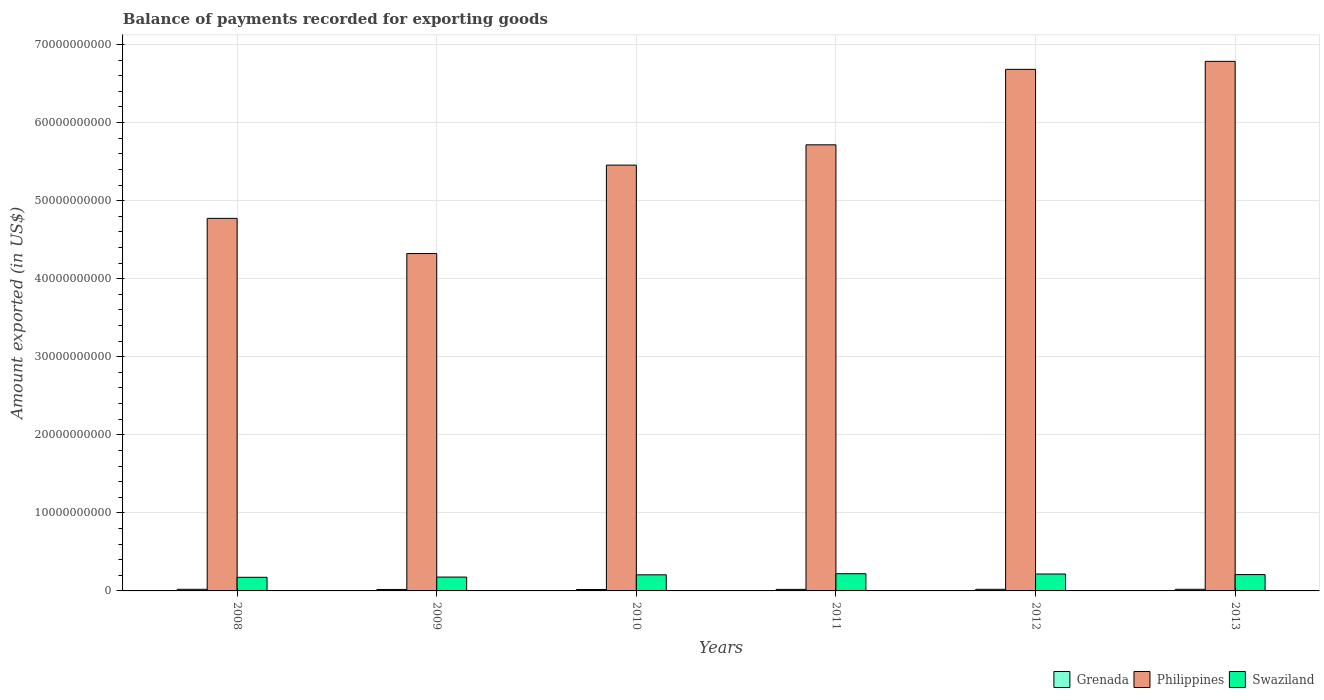How many groups of bars are there?
Provide a short and direct response. 6. Are the number of bars per tick equal to the number of legend labels?
Keep it short and to the point. Yes. Are the number of bars on each tick of the X-axis equal?
Your answer should be very brief. Yes. In how many cases, is the number of bars for a given year not equal to the number of legend labels?
Offer a very short reply. 0. What is the amount exported in Swaziland in 2013?
Provide a succinct answer. 2.09e+09. Across all years, what is the maximum amount exported in Swaziland?
Provide a succinct answer. 2.21e+09. Across all years, what is the minimum amount exported in Philippines?
Make the answer very short. 4.32e+1. In which year was the amount exported in Grenada maximum?
Your response must be concise. 2013. What is the total amount exported in Grenada in the graph?
Provide a short and direct response. 1.19e+09. What is the difference between the amount exported in Grenada in 2012 and that in 2013?
Ensure brevity in your answer.  -3.25e+06. What is the difference between the amount exported in Swaziland in 2008 and the amount exported in Grenada in 2012?
Ensure brevity in your answer.  1.54e+09. What is the average amount exported in Swaziland per year?
Your response must be concise. 2.01e+09. In the year 2008, what is the difference between the amount exported in Philippines and amount exported in Grenada?
Provide a short and direct response. 4.75e+1. In how many years, is the amount exported in Swaziland greater than 34000000000 US$?
Keep it short and to the point. 0. What is the ratio of the amount exported in Grenada in 2012 to that in 2013?
Make the answer very short. 0.98. What is the difference between the highest and the second highest amount exported in Grenada?
Make the answer very short. 1.94e+06. What is the difference between the highest and the lowest amount exported in Philippines?
Offer a terse response. 2.46e+1. What does the 3rd bar from the left in 2012 represents?
Make the answer very short. Swaziland. What does the 3rd bar from the right in 2008 represents?
Make the answer very short. Grenada. Is it the case that in every year, the sum of the amount exported in Swaziland and amount exported in Philippines is greater than the amount exported in Grenada?
Make the answer very short. Yes. What is the difference between two consecutive major ticks on the Y-axis?
Provide a short and direct response. 1.00e+1. Does the graph contain grids?
Give a very brief answer. Yes. How many legend labels are there?
Provide a short and direct response. 3. How are the legend labels stacked?
Make the answer very short. Horizontal. What is the title of the graph?
Your response must be concise. Balance of payments recorded for exporting goods. Does "Brazil" appear as one of the legend labels in the graph?
Your response must be concise. No. What is the label or title of the Y-axis?
Ensure brevity in your answer.  Amount exported (in US$). What is the Amount exported (in US$) of Grenada in 2008?
Provide a succinct answer. 2.08e+08. What is the Amount exported (in US$) in Philippines in 2008?
Give a very brief answer. 4.77e+1. What is the Amount exported (in US$) in Swaziland in 2008?
Give a very brief answer. 1.74e+09. What is the Amount exported (in US$) of Grenada in 2009?
Make the answer very short. 1.87e+08. What is the Amount exported (in US$) in Philippines in 2009?
Offer a very short reply. 4.32e+1. What is the Amount exported (in US$) of Swaziland in 2009?
Offer a terse response. 1.78e+09. What is the Amount exported (in US$) of Grenada in 2010?
Provide a short and direct response. 1.84e+08. What is the Amount exported (in US$) in Philippines in 2010?
Offer a terse response. 5.46e+1. What is the Amount exported (in US$) of Swaziland in 2010?
Your response must be concise. 2.06e+09. What is the Amount exported (in US$) in Grenada in 2011?
Give a very brief answer. 1.96e+08. What is the Amount exported (in US$) of Philippines in 2011?
Ensure brevity in your answer.  5.72e+1. What is the Amount exported (in US$) of Swaziland in 2011?
Ensure brevity in your answer.  2.21e+09. What is the Amount exported (in US$) of Grenada in 2012?
Ensure brevity in your answer.  2.06e+08. What is the Amount exported (in US$) in Philippines in 2012?
Your response must be concise. 6.68e+1. What is the Amount exported (in US$) in Swaziland in 2012?
Keep it short and to the point. 2.17e+09. What is the Amount exported (in US$) of Grenada in 2013?
Ensure brevity in your answer.  2.10e+08. What is the Amount exported (in US$) in Philippines in 2013?
Keep it short and to the point. 6.78e+1. What is the Amount exported (in US$) in Swaziland in 2013?
Provide a short and direct response. 2.09e+09. Across all years, what is the maximum Amount exported (in US$) of Grenada?
Your response must be concise. 2.10e+08. Across all years, what is the maximum Amount exported (in US$) in Philippines?
Your response must be concise. 6.78e+1. Across all years, what is the maximum Amount exported (in US$) in Swaziland?
Ensure brevity in your answer.  2.21e+09. Across all years, what is the minimum Amount exported (in US$) in Grenada?
Your answer should be very brief. 1.84e+08. Across all years, what is the minimum Amount exported (in US$) of Philippines?
Give a very brief answer. 4.32e+1. Across all years, what is the minimum Amount exported (in US$) of Swaziland?
Make the answer very short. 1.74e+09. What is the total Amount exported (in US$) of Grenada in the graph?
Give a very brief answer. 1.19e+09. What is the total Amount exported (in US$) of Philippines in the graph?
Provide a succinct answer. 3.37e+11. What is the total Amount exported (in US$) of Swaziland in the graph?
Ensure brevity in your answer.  1.20e+1. What is the difference between the Amount exported (in US$) in Grenada in 2008 and that in 2009?
Keep it short and to the point. 2.06e+07. What is the difference between the Amount exported (in US$) of Philippines in 2008 and that in 2009?
Provide a short and direct response. 4.51e+09. What is the difference between the Amount exported (in US$) in Swaziland in 2008 and that in 2009?
Your response must be concise. -3.12e+07. What is the difference between the Amount exported (in US$) of Grenada in 2008 and that in 2010?
Offer a very short reply. 2.40e+07. What is the difference between the Amount exported (in US$) in Philippines in 2008 and that in 2010?
Your response must be concise. -6.82e+09. What is the difference between the Amount exported (in US$) of Swaziland in 2008 and that in 2010?
Your response must be concise. -3.19e+08. What is the difference between the Amount exported (in US$) of Grenada in 2008 and that in 2011?
Make the answer very short. 1.16e+07. What is the difference between the Amount exported (in US$) in Philippines in 2008 and that in 2011?
Provide a short and direct response. -9.42e+09. What is the difference between the Amount exported (in US$) in Swaziland in 2008 and that in 2011?
Provide a short and direct response. -4.61e+08. What is the difference between the Amount exported (in US$) of Grenada in 2008 and that in 2012?
Provide a short and direct response. 1.31e+06. What is the difference between the Amount exported (in US$) of Philippines in 2008 and that in 2012?
Your answer should be compact. -1.91e+1. What is the difference between the Amount exported (in US$) in Swaziland in 2008 and that in 2012?
Your response must be concise. -4.23e+08. What is the difference between the Amount exported (in US$) in Grenada in 2008 and that in 2013?
Your response must be concise. -1.94e+06. What is the difference between the Amount exported (in US$) of Philippines in 2008 and that in 2013?
Offer a very short reply. -2.01e+1. What is the difference between the Amount exported (in US$) in Swaziland in 2008 and that in 2013?
Provide a short and direct response. -3.48e+08. What is the difference between the Amount exported (in US$) in Grenada in 2009 and that in 2010?
Give a very brief answer. 3.48e+06. What is the difference between the Amount exported (in US$) in Philippines in 2009 and that in 2010?
Provide a short and direct response. -1.13e+1. What is the difference between the Amount exported (in US$) in Swaziland in 2009 and that in 2010?
Offer a very short reply. -2.87e+08. What is the difference between the Amount exported (in US$) of Grenada in 2009 and that in 2011?
Offer a terse response. -8.94e+06. What is the difference between the Amount exported (in US$) of Philippines in 2009 and that in 2011?
Keep it short and to the point. -1.39e+1. What is the difference between the Amount exported (in US$) in Swaziland in 2009 and that in 2011?
Keep it short and to the point. -4.30e+08. What is the difference between the Amount exported (in US$) in Grenada in 2009 and that in 2012?
Offer a very short reply. -1.93e+07. What is the difference between the Amount exported (in US$) of Philippines in 2009 and that in 2012?
Your answer should be compact. -2.36e+1. What is the difference between the Amount exported (in US$) in Swaziland in 2009 and that in 2012?
Provide a succinct answer. -3.92e+08. What is the difference between the Amount exported (in US$) of Grenada in 2009 and that in 2013?
Offer a terse response. -2.25e+07. What is the difference between the Amount exported (in US$) of Philippines in 2009 and that in 2013?
Keep it short and to the point. -2.46e+1. What is the difference between the Amount exported (in US$) of Swaziland in 2009 and that in 2013?
Your response must be concise. -3.17e+08. What is the difference between the Amount exported (in US$) of Grenada in 2010 and that in 2011?
Provide a short and direct response. -1.24e+07. What is the difference between the Amount exported (in US$) in Philippines in 2010 and that in 2011?
Your answer should be compact. -2.60e+09. What is the difference between the Amount exported (in US$) in Swaziland in 2010 and that in 2011?
Offer a terse response. -1.43e+08. What is the difference between the Amount exported (in US$) in Grenada in 2010 and that in 2012?
Your answer should be very brief. -2.27e+07. What is the difference between the Amount exported (in US$) of Philippines in 2010 and that in 2012?
Ensure brevity in your answer.  -1.23e+1. What is the difference between the Amount exported (in US$) in Swaziland in 2010 and that in 2012?
Ensure brevity in your answer.  -1.05e+08. What is the difference between the Amount exported (in US$) of Grenada in 2010 and that in 2013?
Provide a succinct answer. -2.60e+07. What is the difference between the Amount exported (in US$) of Philippines in 2010 and that in 2013?
Ensure brevity in your answer.  -1.33e+1. What is the difference between the Amount exported (in US$) in Swaziland in 2010 and that in 2013?
Keep it short and to the point. -2.98e+07. What is the difference between the Amount exported (in US$) of Grenada in 2011 and that in 2012?
Make the answer very short. -1.03e+07. What is the difference between the Amount exported (in US$) of Philippines in 2011 and that in 2012?
Offer a terse response. -9.67e+09. What is the difference between the Amount exported (in US$) of Swaziland in 2011 and that in 2012?
Provide a short and direct response. 3.77e+07. What is the difference between the Amount exported (in US$) in Grenada in 2011 and that in 2013?
Your answer should be compact. -1.36e+07. What is the difference between the Amount exported (in US$) of Philippines in 2011 and that in 2013?
Offer a very short reply. -1.07e+1. What is the difference between the Amount exported (in US$) in Swaziland in 2011 and that in 2013?
Your answer should be compact. 1.13e+08. What is the difference between the Amount exported (in US$) of Grenada in 2012 and that in 2013?
Offer a terse response. -3.25e+06. What is the difference between the Amount exported (in US$) in Philippines in 2012 and that in 2013?
Offer a very short reply. -1.02e+09. What is the difference between the Amount exported (in US$) of Swaziland in 2012 and that in 2013?
Offer a terse response. 7.50e+07. What is the difference between the Amount exported (in US$) of Grenada in 2008 and the Amount exported (in US$) of Philippines in 2009?
Provide a succinct answer. -4.30e+1. What is the difference between the Amount exported (in US$) of Grenada in 2008 and the Amount exported (in US$) of Swaziland in 2009?
Provide a succinct answer. -1.57e+09. What is the difference between the Amount exported (in US$) of Philippines in 2008 and the Amount exported (in US$) of Swaziland in 2009?
Your answer should be compact. 4.60e+1. What is the difference between the Amount exported (in US$) in Grenada in 2008 and the Amount exported (in US$) in Philippines in 2010?
Your response must be concise. -5.43e+1. What is the difference between the Amount exported (in US$) in Grenada in 2008 and the Amount exported (in US$) in Swaziland in 2010?
Make the answer very short. -1.86e+09. What is the difference between the Amount exported (in US$) of Philippines in 2008 and the Amount exported (in US$) of Swaziland in 2010?
Offer a terse response. 4.57e+1. What is the difference between the Amount exported (in US$) of Grenada in 2008 and the Amount exported (in US$) of Philippines in 2011?
Make the answer very short. -5.69e+1. What is the difference between the Amount exported (in US$) of Grenada in 2008 and the Amount exported (in US$) of Swaziland in 2011?
Give a very brief answer. -2.00e+09. What is the difference between the Amount exported (in US$) of Philippines in 2008 and the Amount exported (in US$) of Swaziland in 2011?
Offer a very short reply. 4.55e+1. What is the difference between the Amount exported (in US$) of Grenada in 2008 and the Amount exported (in US$) of Philippines in 2012?
Give a very brief answer. -6.66e+1. What is the difference between the Amount exported (in US$) in Grenada in 2008 and the Amount exported (in US$) in Swaziland in 2012?
Your answer should be compact. -1.96e+09. What is the difference between the Amount exported (in US$) in Philippines in 2008 and the Amount exported (in US$) in Swaziland in 2012?
Keep it short and to the point. 4.56e+1. What is the difference between the Amount exported (in US$) in Grenada in 2008 and the Amount exported (in US$) in Philippines in 2013?
Ensure brevity in your answer.  -6.76e+1. What is the difference between the Amount exported (in US$) in Grenada in 2008 and the Amount exported (in US$) in Swaziland in 2013?
Keep it short and to the point. -1.88e+09. What is the difference between the Amount exported (in US$) in Philippines in 2008 and the Amount exported (in US$) in Swaziland in 2013?
Provide a succinct answer. 4.56e+1. What is the difference between the Amount exported (in US$) of Grenada in 2009 and the Amount exported (in US$) of Philippines in 2010?
Provide a succinct answer. -5.44e+1. What is the difference between the Amount exported (in US$) in Grenada in 2009 and the Amount exported (in US$) in Swaziland in 2010?
Your response must be concise. -1.88e+09. What is the difference between the Amount exported (in US$) of Philippines in 2009 and the Amount exported (in US$) of Swaziland in 2010?
Offer a very short reply. 4.12e+1. What is the difference between the Amount exported (in US$) in Grenada in 2009 and the Amount exported (in US$) in Philippines in 2011?
Your answer should be compact. -5.70e+1. What is the difference between the Amount exported (in US$) of Grenada in 2009 and the Amount exported (in US$) of Swaziland in 2011?
Offer a terse response. -2.02e+09. What is the difference between the Amount exported (in US$) of Philippines in 2009 and the Amount exported (in US$) of Swaziland in 2011?
Offer a very short reply. 4.10e+1. What is the difference between the Amount exported (in US$) of Grenada in 2009 and the Amount exported (in US$) of Philippines in 2012?
Provide a succinct answer. -6.66e+1. What is the difference between the Amount exported (in US$) in Grenada in 2009 and the Amount exported (in US$) in Swaziland in 2012?
Your response must be concise. -1.98e+09. What is the difference between the Amount exported (in US$) in Philippines in 2009 and the Amount exported (in US$) in Swaziland in 2012?
Make the answer very short. 4.11e+1. What is the difference between the Amount exported (in US$) in Grenada in 2009 and the Amount exported (in US$) in Philippines in 2013?
Offer a terse response. -6.77e+1. What is the difference between the Amount exported (in US$) in Grenada in 2009 and the Amount exported (in US$) in Swaziland in 2013?
Give a very brief answer. -1.91e+09. What is the difference between the Amount exported (in US$) of Philippines in 2009 and the Amount exported (in US$) of Swaziland in 2013?
Your answer should be compact. 4.11e+1. What is the difference between the Amount exported (in US$) of Grenada in 2010 and the Amount exported (in US$) of Philippines in 2011?
Make the answer very short. -5.70e+1. What is the difference between the Amount exported (in US$) in Grenada in 2010 and the Amount exported (in US$) in Swaziland in 2011?
Provide a succinct answer. -2.02e+09. What is the difference between the Amount exported (in US$) of Philippines in 2010 and the Amount exported (in US$) of Swaziland in 2011?
Provide a short and direct response. 5.23e+1. What is the difference between the Amount exported (in US$) of Grenada in 2010 and the Amount exported (in US$) of Philippines in 2012?
Keep it short and to the point. -6.66e+1. What is the difference between the Amount exported (in US$) in Grenada in 2010 and the Amount exported (in US$) in Swaziland in 2012?
Make the answer very short. -1.98e+09. What is the difference between the Amount exported (in US$) of Philippines in 2010 and the Amount exported (in US$) of Swaziland in 2012?
Provide a short and direct response. 5.24e+1. What is the difference between the Amount exported (in US$) of Grenada in 2010 and the Amount exported (in US$) of Philippines in 2013?
Your answer should be very brief. -6.77e+1. What is the difference between the Amount exported (in US$) in Grenada in 2010 and the Amount exported (in US$) in Swaziland in 2013?
Give a very brief answer. -1.91e+09. What is the difference between the Amount exported (in US$) of Philippines in 2010 and the Amount exported (in US$) of Swaziland in 2013?
Offer a very short reply. 5.25e+1. What is the difference between the Amount exported (in US$) in Grenada in 2011 and the Amount exported (in US$) in Philippines in 2012?
Provide a short and direct response. -6.66e+1. What is the difference between the Amount exported (in US$) of Grenada in 2011 and the Amount exported (in US$) of Swaziland in 2012?
Your answer should be compact. -1.97e+09. What is the difference between the Amount exported (in US$) of Philippines in 2011 and the Amount exported (in US$) of Swaziland in 2012?
Your answer should be compact. 5.50e+1. What is the difference between the Amount exported (in US$) of Grenada in 2011 and the Amount exported (in US$) of Philippines in 2013?
Provide a short and direct response. -6.77e+1. What is the difference between the Amount exported (in US$) in Grenada in 2011 and the Amount exported (in US$) in Swaziland in 2013?
Offer a terse response. -1.90e+09. What is the difference between the Amount exported (in US$) of Philippines in 2011 and the Amount exported (in US$) of Swaziland in 2013?
Offer a terse response. 5.51e+1. What is the difference between the Amount exported (in US$) in Grenada in 2012 and the Amount exported (in US$) in Philippines in 2013?
Provide a succinct answer. -6.76e+1. What is the difference between the Amount exported (in US$) in Grenada in 2012 and the Amount exported (in US$) in Swaziland in 2013?
Provide a succinct answer. -1.89e+09. What is the difference between the Amount exported (in US$) in Philippines in 2012 and the Amount exported (in US$) in Swaziland in 2013?
Provide a short and direct response. 6.47e+1. What is the average Amount exported (in US$) in Grenada per year?
Your response must be concise. 1.99e+08. What is the average Amount exported (in US$) of Philippines per year?
Make the answer very short. 5.62e+1. What is the average Amount exported (in US$) in Swaziland per year?
Ensure brevity in your answer.  2.01e+09. In the year 2008, what is the difference between the Amount exported (in US$) of Grenada and Amount exported (in US$) of Philippines?
Offer a terse response. -4.75e+1. In the year 2008, what is the difference between the Amount exported (in US$) of Grenada and Amount exported (in US$) of Swaziland?
Your response must be concise. -1.54e+09. In the year 2008, what is the difference between the Amount exported (in US$) in Philippines and Amount exported (in US$) in Swaziland?
Your response must be concise. 4.60e+1. In the year 2009, what is the difference between the Amount exported (in US$) of Grenada and Amount exported (in US$) of Philippines?
Make the answer very short. -4.30e+1. In the year 2009, what is the difference between the Amount exported (in US$) of Grenada and Amount exported (in US$) of Swaziland?
Provide a succinct answer. -1.59e+09. In the year 2009, what is the difference between the Amount exported (in US$) of Philippines and Amount exported (in US$) of Swaziland?
Provide a short and direct response. 4.15e+1. In the year 2010, what is the difference between the Amount exported (in US$) in Grenada and Amount exported (in US$) in Philippines?
Make the answer very short. -5.44e+1. In the year 2010, what is the difference between the Amount exported (in US$) in Grenada and Amount exported (in US$) in Swaziland?
Your answer should be very brief. -1.88e+09. In the year 2010, what is the difference between the Amount exported (in US$) in Philippines and Amount exported (in US$) in Swaziland?
Offer a very short reply. 5.25e+1. In the year 2011, what is the difference between the Amount exported (in US$) in Grenada and Amount exported (in US$) in Philippines?
Your answer should be compact. -5.70e+1. In the year 2011, what is the difference between the Amount exported (in US$) in Grenada and Amount exported (in US$) in Swaziland?
Offer a terse response. -2.01e+09. In the year 2011, what is the difference between the Amount exported (in US$) of Philippines and Amount exported (in US$) of Swaziland?
Ensure brevity in your answer.  5.49e+1. In the year 2012, what is the difference between the Amount exported (in US$) of Grenada and Amount exported (in US$) of Philippines?
Give a very brief answer. -6.66e+1. In the year 2012, what is the difference between the Amount exported (in US$) of Grenada and Amount exported (in US$) of Swaziland?
Offer a terse response. -1.96e+09. In the year 2012, what is the difference between the Amount exported (in US$) in Philippines and Amount exported (in US$) in Swaziland?
Offer a terse response. 6.47e+1. In the year 2013, what is the difference between the Amount exported (in US$) of Grenada and Amount exported (in US$) of Philippines?
Your answer should be very brief. -6.76e+1. In the year 2013, what is the difference between the Amount exported (in US$) of Grenada and Amount exported (in US$) of Swaziland?
Offer a very short reply. -1.88e+09. In the year 2013, what is the difference between the Amount exported (in US$) of Philippines and Amount exported (in US$) of Swaziland?
Keep it short and to the point. 6.58e+1. What is the ratio of the Amount exported (in US$) of Grenada in 2008 to that in 2009?
Keep it short and to the point. 1.11. What is the ratio of the Amount exported (in US$) in Philippines in 2008 to that in 2009?
Provide a short and direct response. 1.1. What is the ratio of the Amount exported (in US$) in Swaziland in 2008 to that in 2009?
Offer a terse response. 0.98. What is the ratio of the Amount exported (in US$) in Grenada in 2008 to that in 2010?
Keep it short and to the point. 1.13. What is the ratio of the Amount exported (in US$) in Swaziland in 2008 to that in 2010?
Ensure brevity in your answer.  0.85. What is the ratio of the Amount exported (in US$) in Grenada in 2008 to that in 2011?
Provide a short and direct response. 1.06. What is the ratio of the Amount exported (in US$) in Philippines in 2008 to that in 2011?
Provide a succinct answer. 0.84. What is the ratio of the Amount exported (in US$) of Swaziland in 2008 to that in 2011?
Ensure brevity in your answer.  0.79. What is the ratio of the Amount exported (in US$) in Grenada in 2008 to that in 2012?
Ensure brevity in your answer.  1.01. What is the ratio of the Amount exported (in US$) in Philippines in 2008 to that in 2012?
Ensure brevity in your answer.  0.71. What is the ratio of the Amount exported (in US$) in Swaziland in 2008 to that in 2012?
Your response must be concise. 0.8. What is the ratio of the Amount exported (in US$) of Grenada in 2008 to that in 2013?
Your response must be concise. 0.99. What is the ratio of the Amount exported (in US$) of Philippines in 2008 to that in 2013?
Keep it short and to the point. 0.7. What is the ratio of the Amount exported (in US$) of Swaziland in 2008 to that in 2013?
Make the answer very short. 0.83. What is the ratio of the Amount exported (in US$) of Grenada in 2009 to that in 2010?
Make the answer very short. 1.02. What is the ratio of the Amount exported (in US$) in Philippines in 2009 to that in 2010?
Offer a terse response. 0.79. What is the ratio of the Amount exported (in US$) of Swaziland in 2009 to that in 2010?
Your answer should be very brief. 0.86. What is the ratio of the Amount exported (in US$) of Grenada in 2009 to that in 2011?
Give a very brief answer. 0.95. What is the ratio of the Amount exported (in US$) of Philippines in 2009 to that in 2011?
Provide a succinct answer. 0.76. What is the ratio of the Amount exported (in US$) in Swaziland in 2009 to that in 2011?
Make the answer very short. 0.81. What is the ratio of the Amount exported (in US$) of Grenada in 2009 to that in 2012?
Offer a terse response. 0.91. What is the ratio of the Amount exported (in US$) in Philippines in 2009 to that in 2012?
Your response must be concise. 0.65. What is the ratio of the Amount exported (in US$) of Swaziland in 2009 to that in 2012?
Make the answer very short. 0.82. What is the ratio of the Amount exported (in US$) in Grenada in 2009 to that in 2013?
Keep it short and to the point. 0.89. What is the ratio of the Amount exported (in US$) in Philippines in 2009 to that in 2013?
Offer a very short reply. 0.64. What is the ratio of the Amount exported (in US$) of Swaziland in 2009 to that in 2013?
Offer a terse response. 0.85. What is the ratio of the Amount exported (in US$) of Grenada in 2010 to that in 2011?
Make the answer very short. 0.94. What is the ratio of the Amount exported (in US$) of Philippines in 2010 to that in 2011?
Make the answer very short. 0.95. What is the ratio of the Amount exported (in US$) of Swaziland in 2010 to that in 2011?
Ensure brevity in your answer.  0.94. What is the ratio of the Amount exported (in US$) in Grenada in 2010 to that in 2012?
Ensure brevity in your answer.  0.89. What is the ratio of the Amount exported (in US$) of Philippines in 2010 to that in 2012?
Keep it short and to the point. 0.82. What is the ratio of the Amount exported (in US$) in Swaziland in 2010 to that in 2012?
Your answer should be compact. 0.95. What is the ratio of the Amount exported (in US$) in Grenada in 2010 to that in 2013?
Your response must be concise. 0.88. What is the ratio of the Amount exported (in US$) in Philippines in 2010 to that in 2013?
Provide a succinct answer. 0.8. What is the ratio of the Amount exported (in US$) of Swaziland in 2010 to that in 2013?
Your answer should be very brief. 0.99. What is the ratio of the Amount exported (in US$) in Grenada in 2011 to that in 2012?
Your response must be concise. 0.95. What is the ratio of the Amount exported (in US$) of Philippines in 2011 to that in 2012?
Keep it short and to the point. 0.86. What is the ratio of the Amount exported (in US$) of Swaziland in 2011 to that in 2012?
Offer a very short reply. 1.02. What is the ratio of the Amount exported (in US$) in Grenada in 2011 to that in 2013?
Ensure brevity in your answer.  0.94. What is the ratio of the Amount exported (in US$) of Philippines in 2011 to that in 2013?
Make the answer very short. 0.84. What is the ratio of the Amount exported (in US$) of Swaziland in 2011 to that in 2013?
Ensure brevity in your answer.  1.05. What is the ratio of the Amount exported (in US$) of Grenada in 2012 to that in 2013?
Provide a short and direct response. 0.98. What is the ratio of the Amount exported (in US$) of Philippines in 2012 to that in 2013?
Provide a short and direct response. 0.98. What is the ratio of the Amount exported (in US$) in Swaziland in 2012 to that in 2013?
Offer a very short reply. 1.04. What is the difference between the highest and the second highest Amount exported (in US$) of Grenada?
Your answer should be compact. 1.94e+06. What is the difference between the highest and the second highest Amount exported (in US$) in Philippines?
Your response must be concise. 1.02e+09. What is the difference between the highest and the second highest Amount exported (in US$) in Swaziland?
Your response must be concise. 3.77e+07. What is the difference between the highest and the lowest Amount exported (in US$) in Grenada?
Your answer should be very brief. 2.60e+07. What is the difference between the highest and the lowest Amount exported (in US$) of Philippines?
Ensure brevity in your answer.  2.46e+1. What is the difference between the highest and the lowest Amount exported (in US$) of Swaziland?
Ensure brevity in your answer.  4.61e+08. 